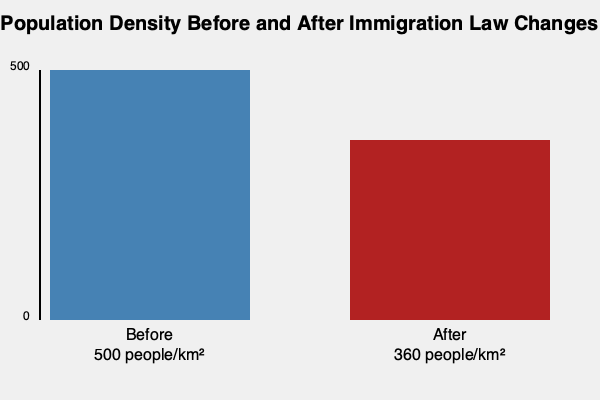Based on the population density charts before and after immigration law changes, what percentage decrease in population density occurred? Round your answer to the nearest whole number. To calculate the percentage decrease in population density, we'll follow these steps:

1. Identify the initial (before) and final (after) population densities:
   - Before: 500 people/km²
   - After: 360 people/km²

2. Calculate the absolute decrease:
   $500 - 360 = 140$ people/km²

3. Calculate the percentage decrease using the formula:
   Percentage decrease = $\frac{\text{Decrease}}{\text{Original Value}} \times 100\%$

   $\frac{140}{500} \times 100\% = 0.28 \times 100\% = 28\%$

4. Round to the nearest whole number:
   28% (no rounding needed in this case)

Therefore, the population density decreased by 28% after the immigration law changes.
Answer: 28% 